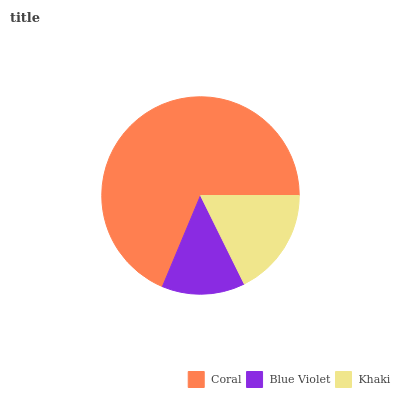Is Blue Violet the minimum?
Answer yes or no. Yes. Is Coral the maximum?
Answer yes or no. Yes. Is Khaki the minimum?
Answer yes or no. No. Is Khaki the maximum?
Answer yes or no. No. Is Khaki greater than Blue Violet?
Answer yes or no. Yes. Is Blue Violet less than Khaki?
Answer yes or no. Yes. Is Blue Violet greater than Khaki?
Answer yes or no. No. Is Khaki less than Blue Violet?
Answer yes or no. No. Is Khaki the high median?
Answer yes or no. Yes. Is Khaki the low median?
Answer yes or no. Yes. Is Blue Violet the high median?
Answer yes or no. No. Is Blue Violet the low median?
Answer yes or no. No. 